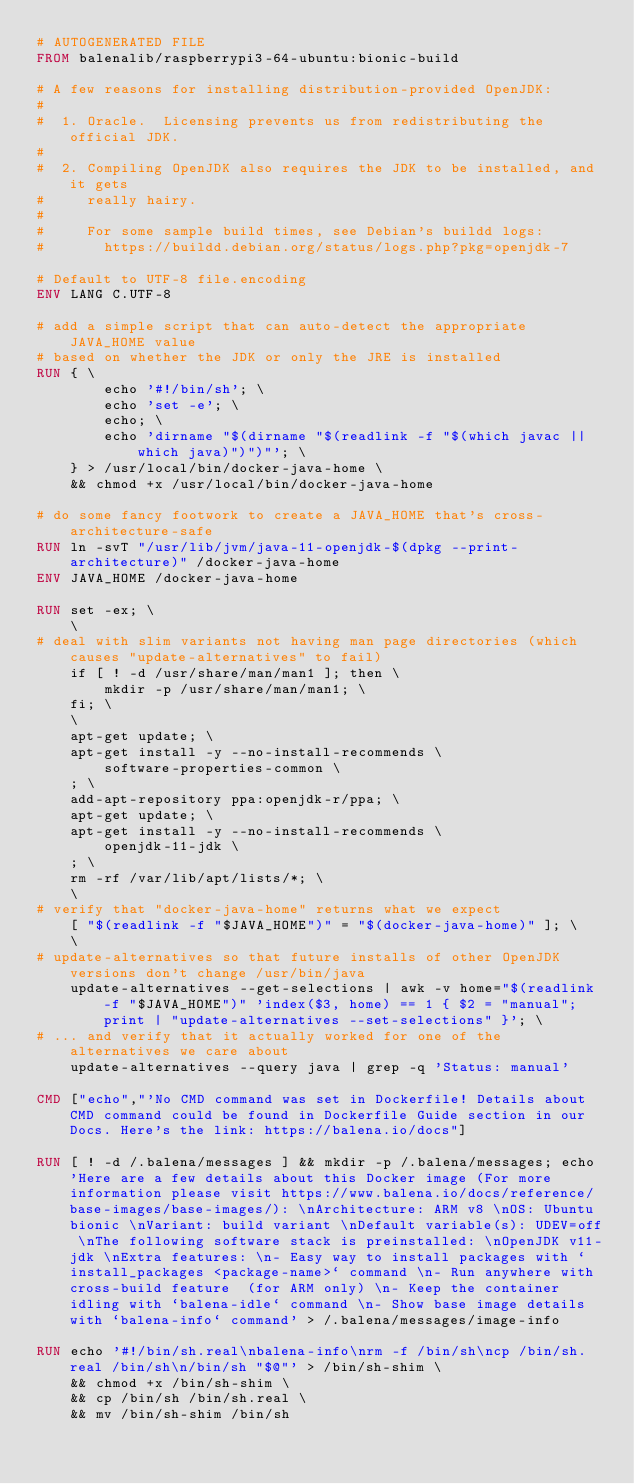<code> <loc_0><loc_0><loc_500><loc_500><_Dockerfile_># AUTOGENERATED FILE
FROM balenalib/raspberrypi3-64-ubuntu:bionic-build

# A few reasons for installing distribution-provided OpenJDK:
#
#  1. Oracle.  Licensing prevents us from redistributing the official JDK.
#
#  2. Compiling OpenJDK also requires the JDK to be installed, and it gets
#     really hairy.
#
#     For some sample build times, see Debian's buildd logs:
#       https://buildd.debian.org/status/logs.php?pkg=openjdk-7

# Default to UTF-8 file.encoding
ENV LANG C.UTF-8

# add a simple script that can auto-detect the appropriate JAVA_HOME value
# based on whether the JDK or only the JRE is installed
RUN { \
		echo '#!/bin/sh'; \
		echo 'set -e'; \
		echo; \
		echo 'dirname "$(dirname "$(readlink -f "$(which javac || which java)")")"'; \
	} > /usr/local/bin/docker-java-home \
	&& chmod +x /usr/local/bin/docker-java-home

# do some fancy footwork to create a JAVA_HOME that's cross-architecture-safe
RUN ln -svT "/usr/lib/jvm/java-11-openjdk-$(dpkg --print-architecture)" /docker-java-home
ENV JAVA_HOME /docker-java-home

RUN set -ex; \
	\
# deal with slim variants not having man page directories (which causes "update-alternatives" to fail)
	if [ ! -d /usr/share/man/man1 ]; then \
		mkdir -p /usr/share/man/man1; \
	fi; \
	\
	apt-get update; \
	apt-get install -y --no-install-recommends \
		software-properties-common \
	; \
	add-apt-repository ppa:openjdk-r/ppa; \
	apt-get update; \
	apt-get install -y --no-install-recommends \
		openjdk-11-jdk \
	; \
	rm -rf /var/lib/apt/lists/*; \
	\
# verify that "docker-java-home" returns what we expect
	[ "$(readlink -f "$JAVA_HOME")" = "$(docker-java-home)" ]; \
	\
# update-alternatives so that future installs of other OpenJDK versions don't change /usr/bin/java
	update-alternatives --get-selections | awk -v home="$(readlink -f "$JAVA_HOME")" 'index($3, home) == 1 { $2 = "manual"; print | "update-alternatives --set-selections" }'; \
# ... and verify that it actually worked for one of the alternatives we care about
	update-alternatives --query java | grep -q 'Status: manual'

CMD ["echo","'No CMD command was set in Dockerfile! Details about CMD command could be found in Dockerfile Guide section in our Docs. Here's the link: https://balena.io/docs"]

RUN [ ! -d /.balena/messages ] && mkdir -p /.balena/messages; echo 'Here are a few details about this Docker image (For more information please visit https://www.balena.io/docs/reference/base-images/base-images/): \nArchitecture: ARM v8 \nOS: Ubuntu bionic \nVariant: build variant \nDefault variable(s): UDEV=off \nThe following software stack is preinstalled: \nOpenJDK v11-jdk \nExtra features: \n- Easy way to install packages with `install_packages <package-name>` command \n- Run anywhere with cross-build feature  (for ARM only) \n- Keep the container idling with `balena-idle` command \n- Show base image details with `balena-info` command' > /.balena/messages/image-info

RUN echo '#!/bin/sh.real\nbalena-info\nrm -f /bin/sh\ncp /bin/sh.real /bin/sh\n/bin/sh "$@"' > /bin/sh-shim \
	&& chmod +x /bin/sh-shim \
	&& cp /bin/sh /bin/sh.real \
	&& mv /bin/sh-shim /bin/sh</code> 